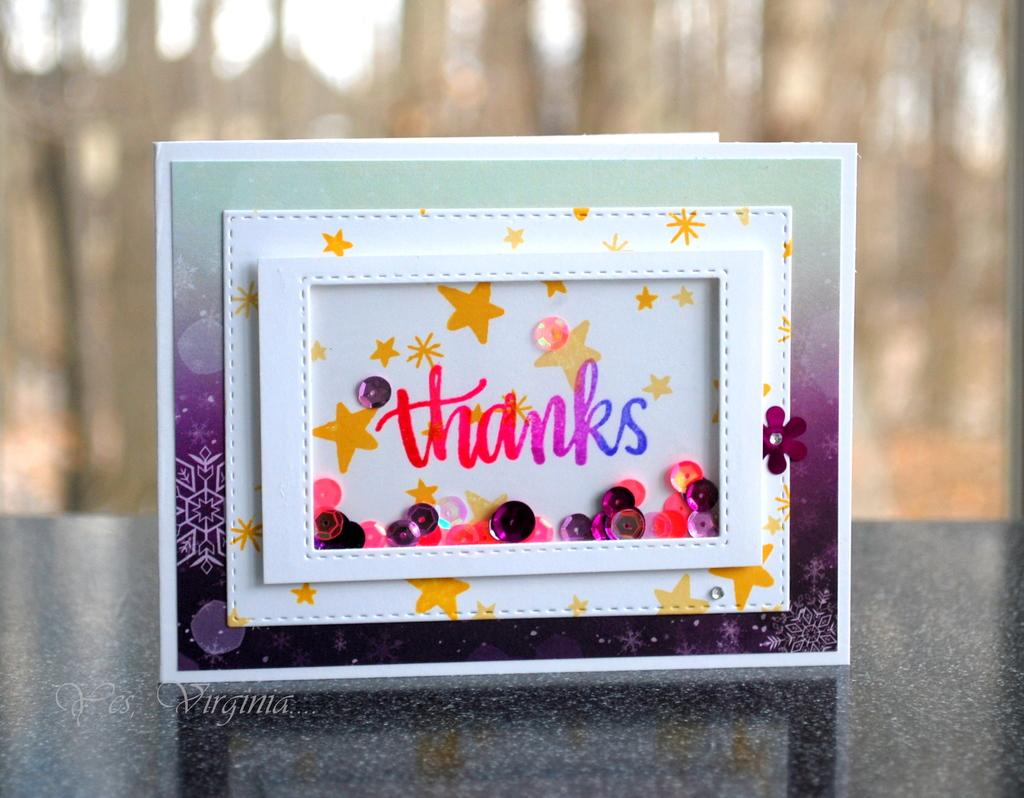Provide a one-sentence caption for the provided image. A very colorful and decorative card that reads thanks on the front. 